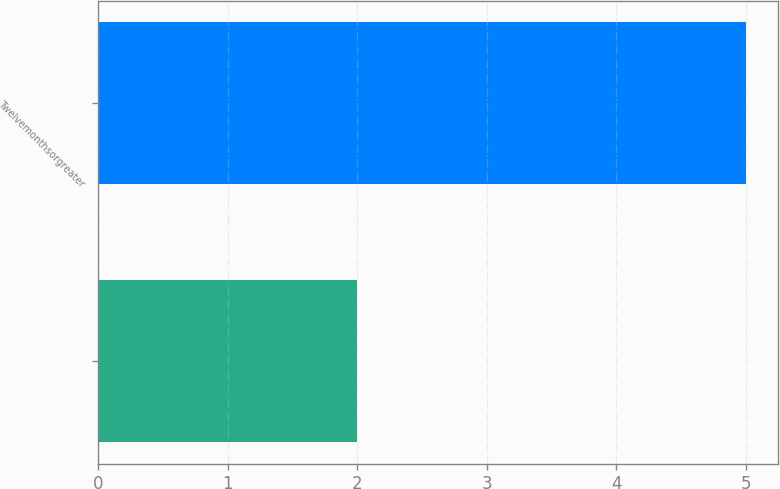Convert chart to OTSL. <chart><loc_0><loc_0><loc_500><loc_500><bar_chart><ecel><fcel>Twelvemonthsorgreater<nl><fcel>2<fcel>5<nl></chart> 